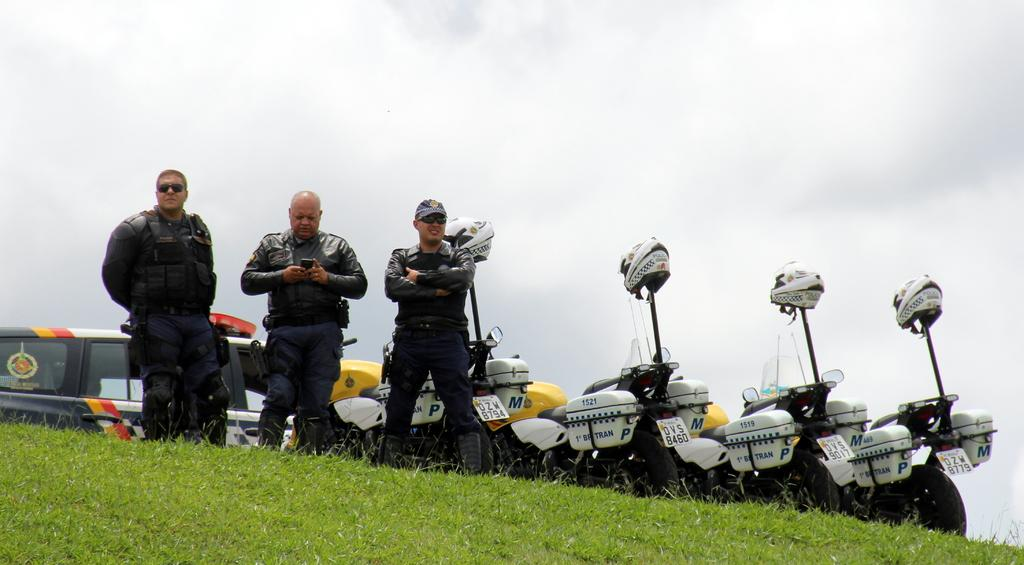How many men are present in the image? There are three men in the image. Where are the men standing? The men are standing on the grass. What can be seen in the background of the image? There are vehicles, helmets, and other objects in the background of the image. What is visible in the sky in the image? The sky is visible in the background of the image. What is the distance between the donkey and the men in the image? There is no donkey present in the image, so it is not possible to determine the distance between a donkey and the men. 